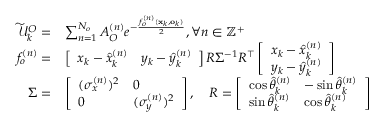<formula> <loc_0><loc_0><loc_500><loc_500>\begin{array} { r l } { \widetilde { \mathcal { U } } _ { k } ^ { O } = } & { \sum _ { n = 1 } ^ { N _ { o } } A _ { O } ^ { ( n ) } e ^ { - \frac { f _ { o } ^ { ( n ) } ( x _ { k } , o _ { k } ) } { 2 } } , \forall n \in \mathbb { Z } ^ { + } } \\ { f _ { o } ^ { ( n ) } = } & { \left [ \begin{array} { l l } { x _ { k } - \widehat { x } _ { k } ^ { ( n ) } } & { y _ { k } - \widehat { y } _ { k } ^ { ( n ) } } \end{array} \right ] R \Sigma ^ { - 1 } R ^ { \intercal } \left [ \begin{array} { l } { x _ { k } - \widehat { x } _ { k } ^ { ( n ) } } \\ { y _ { k } - \widehat { y } _ { k } ^ { ( n ) } } \end{array} \right ] } \\ { \Sigma = } & { \left [ \begin{array} { l l } { { ( \sigma _ { x } ^ { ( n ) } ) ^ { 2 } } } & { 0 } \\ { 0 } & { { ( \sigma _ { y } ^ { ( n ) } ) ^ { 2 } } } \end{array} \right ] , \quad R = \left [ \begin{array} { l l } { \cos \widehat { \theta } _ { k } ^ { ( n ) } } & { - \sin \widehat { \theta } _ { k } ^ { ( n ) } } \\ { \sin \widehat { \theta } _ { k } ^ { ( n ) } } & { \cos \widehat { \theta } _ { k } ^ { ( n ) } } \end{array} \right ] } \end{array}</formula> 